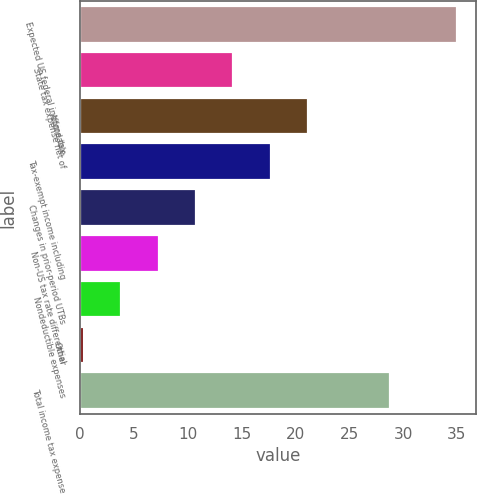Convert chart to OTSL. <chart><loc_0><loc_0><loc_500><loc_500><bar_chart><fcel>Expected US federal income tax<fcel>State tax expense net of<fcel>Affordable<fcel>Tax-exempt income including<fcel>Changes in prior-period UTBs<fcel>Non-US tax rate differential<fcel>Nondeductible expenses<fcel>Other<fcel>Total income tax expense<nl><fcel>35<fcel>14.24<fcel>21.16<fcel>17.7<fcel>10.78<fcel>7.32<fcel>3.86<fcel>0.4<fcel>28.8<nl></chart> 